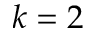Convert formula to latex. <formula><loc_0><loc_0><loc_500><loc_500>k = 2</formula> 